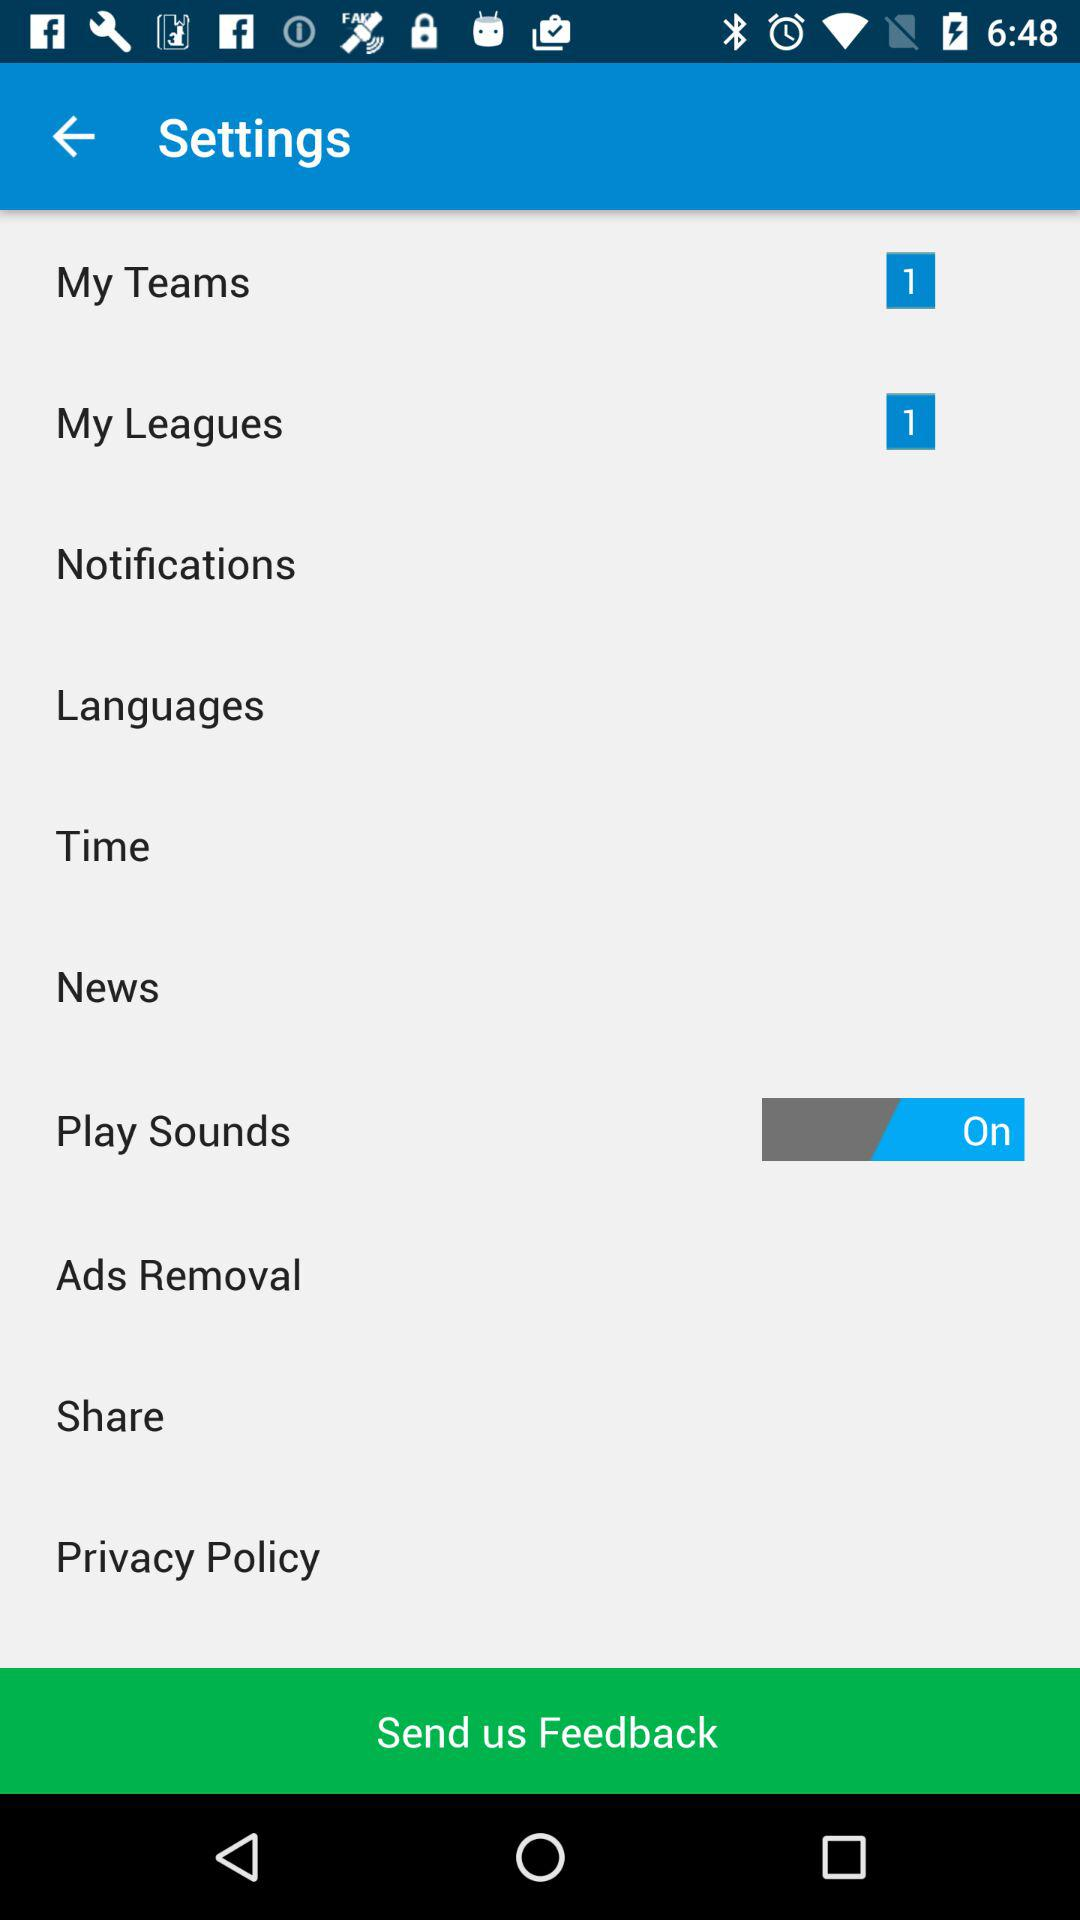What's the status of "Play Sounds"? The status is "on". 